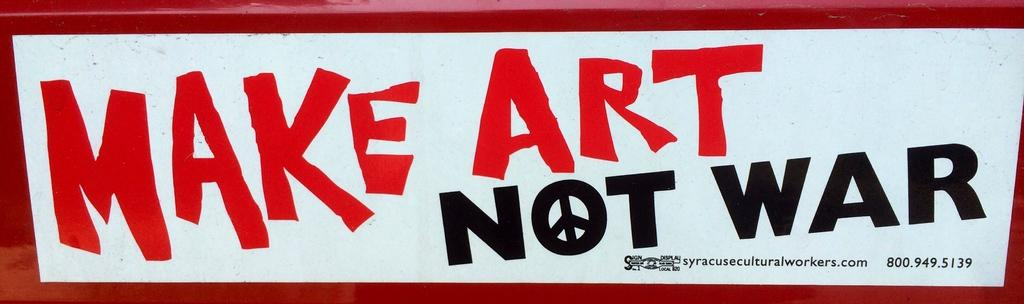<image>
Share a concise interpretation of the image provided. Sign that says "Make art not war" in red and black. 